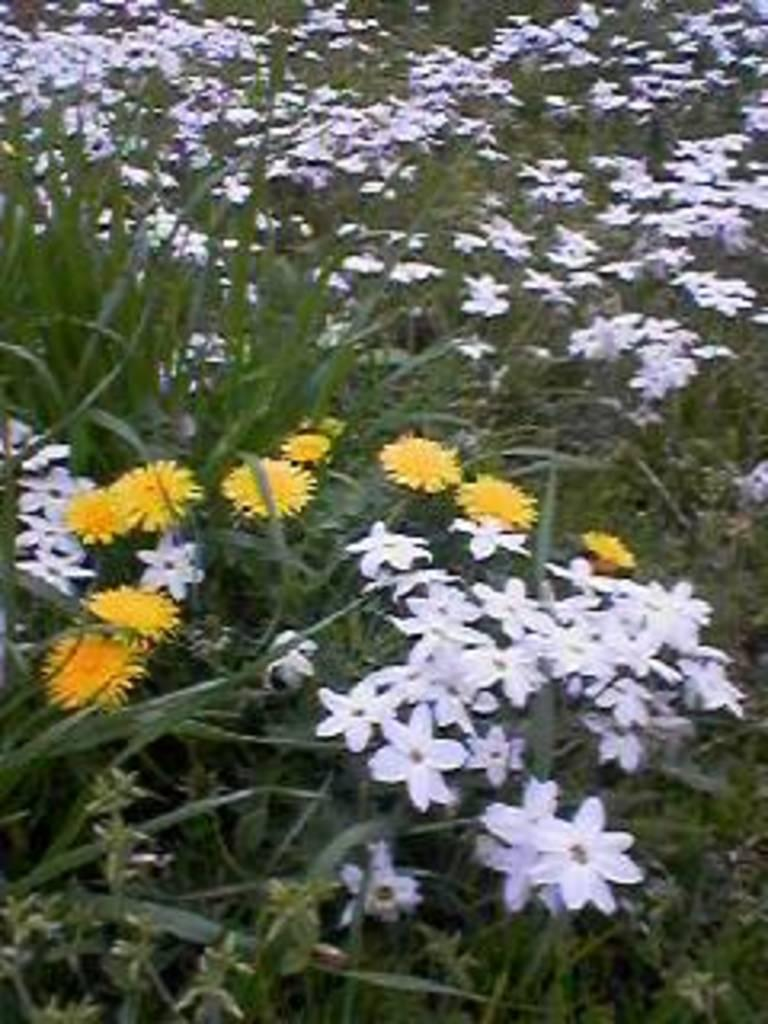What colors are the flowers in the image? The flowers in the image are in yellow and white colors. What color are the plants in the image? The plants in the image are in green color. Can you tell me how many frogs are sitting on the flowers in the image? There are no frogs present in the image; it features flowers and plants. What type of argument is taking place between the flowers in the image? There is no argument taking place between the flowers in the image; they are simply plants and flowers. 